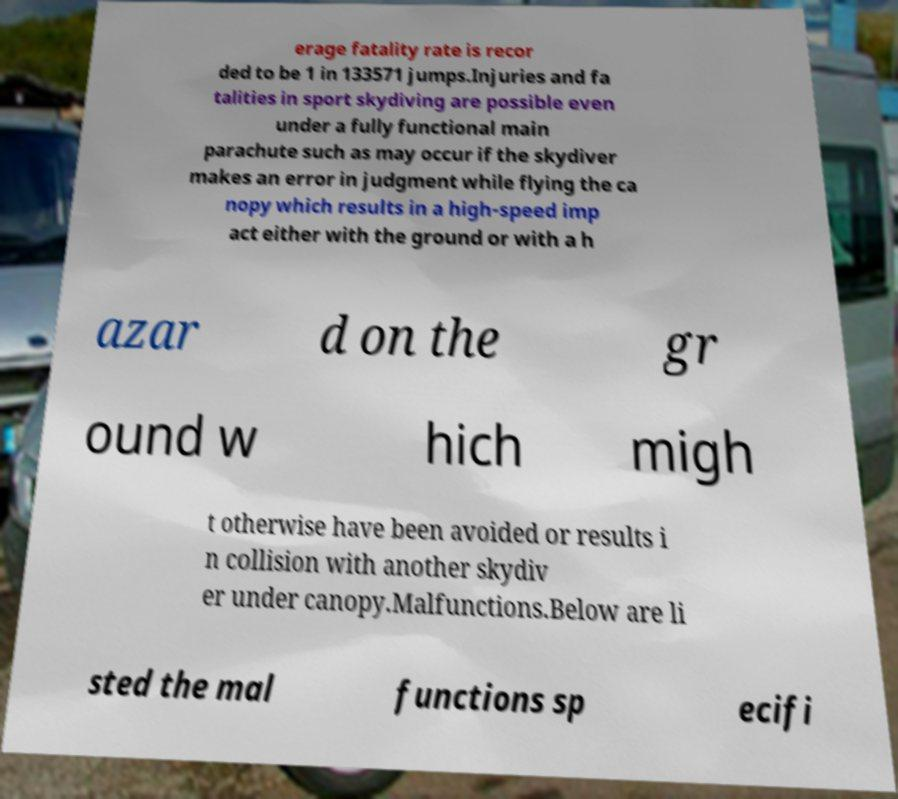Could you extract and type out the text from this image? erage fatality rate is recor ded to be 1 in 133571 jumps.Injuries and fa talities in sport skydiving are possible even under a fully functional main parachute such as may occur if the skydiver makes an error in judgment while flying the ca nopy which results in a high-speed imp act either with the ground or with a h azar d on the gr ound w hich migh t otherwise have been avoided or results i n collision with another skydiv er under canopy.Malfunctions.Below are li sted the mal functions sp ecifi 